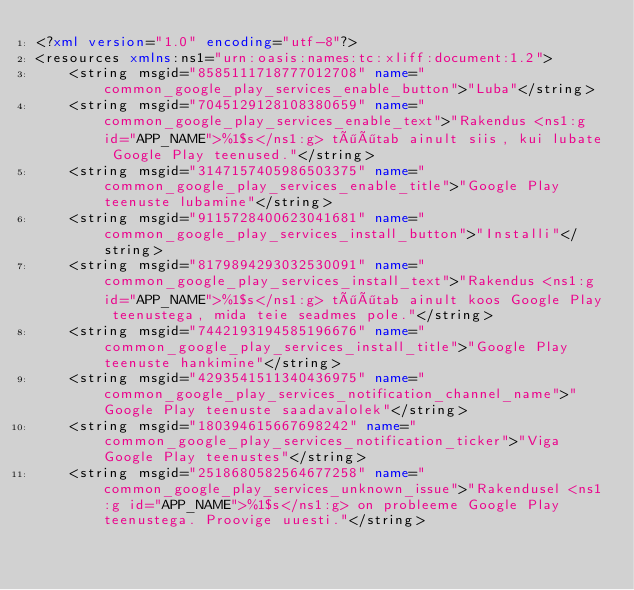<code> <loc_0><loc_0><loc_500><loc_500><_XML_><?xml version="1.0" encoding="utf-8"?>
<resources xmlns:ns1="urn:oasis:names:tc:xliff:document:1.2">
    <string msgid="8585111718777012708" name="common_google_play_services_enable_button">"Luba"</string>
    <string msgid="7045129128108380659" name="common_google_play_services_enable_text">"Rakendus <ns1:g id="APP_NAME">%1$s</ns1:g> töötab ainult siis, kui lubate Google Play teenused."</string>
    <string msgid="3147157405986503375" name="common_google_play_services_enable_title">"Google Play teenuste lubamine"</string>
    <string msgid="9115728400623041681" name="common_google_play_services_install_button">"Installi"</string>
    <string msgid="8179894293032530091" name="common_google_play_services_install_text">"Rakendus <ns1:g id="APP_NAME">%1$s</ns1:g> töötab ainult koos Google Play teenustega, mida teie seadmes pole."</string>
    <string msgid="7442193194585196676" name="common_google_play_services_install_title">"Google Play teenuste hankimine"</string>
    <string msgid="4293541511340436975" name="common_google_play_services_notification_channel_name">"Google Play teenuste saadavalolek"</string>
    <string msgid="180394615667698242" name="common_google_play_services_notification_ticker">"Viga Google Play teenustes"</string>
    <string msgid="2518680582564677258" name="common_google_play_services_unknown_issue">"Rakendusel <ns1:g id="APP_NAME">%1$s</ns1:g> on probleeme Google Play teenustega. Proovige uuesti."</string></code> 